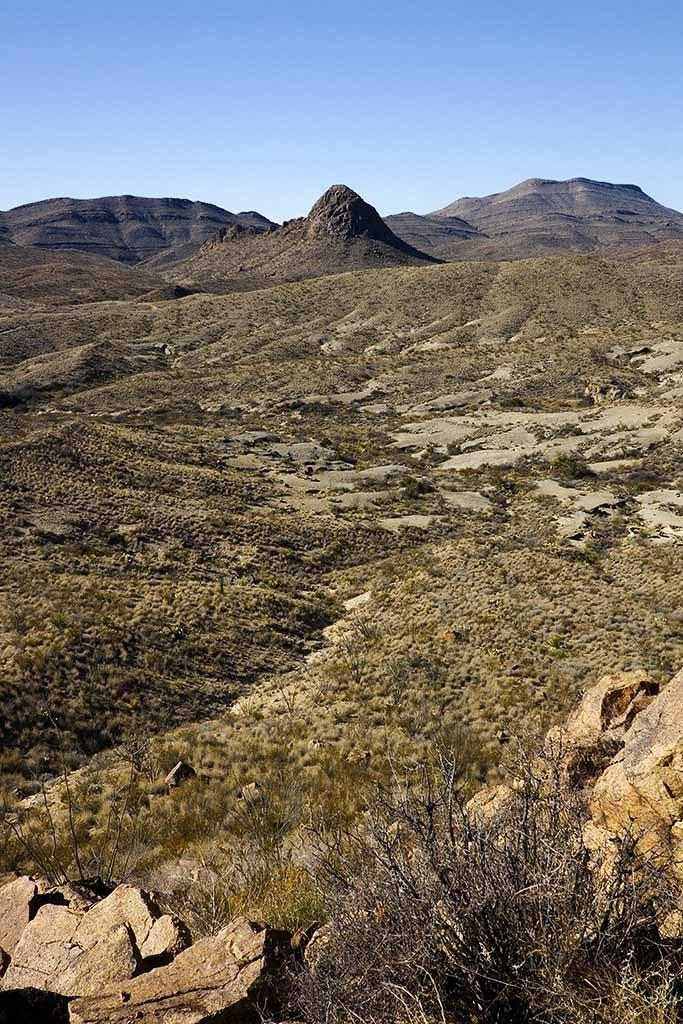What type of natural elements can be seen in the image? There are stones, grass, and hills visible in the image. What is the condition of the plant in the image? The plant in the image is dry. What color is the sky in the image? The sky is pale blue in the image. Can you see any smoke coming from the stones in the image? There is no smoke present in the image; it features stones, grass, a dry plant, hills, and a pale blue sky. 